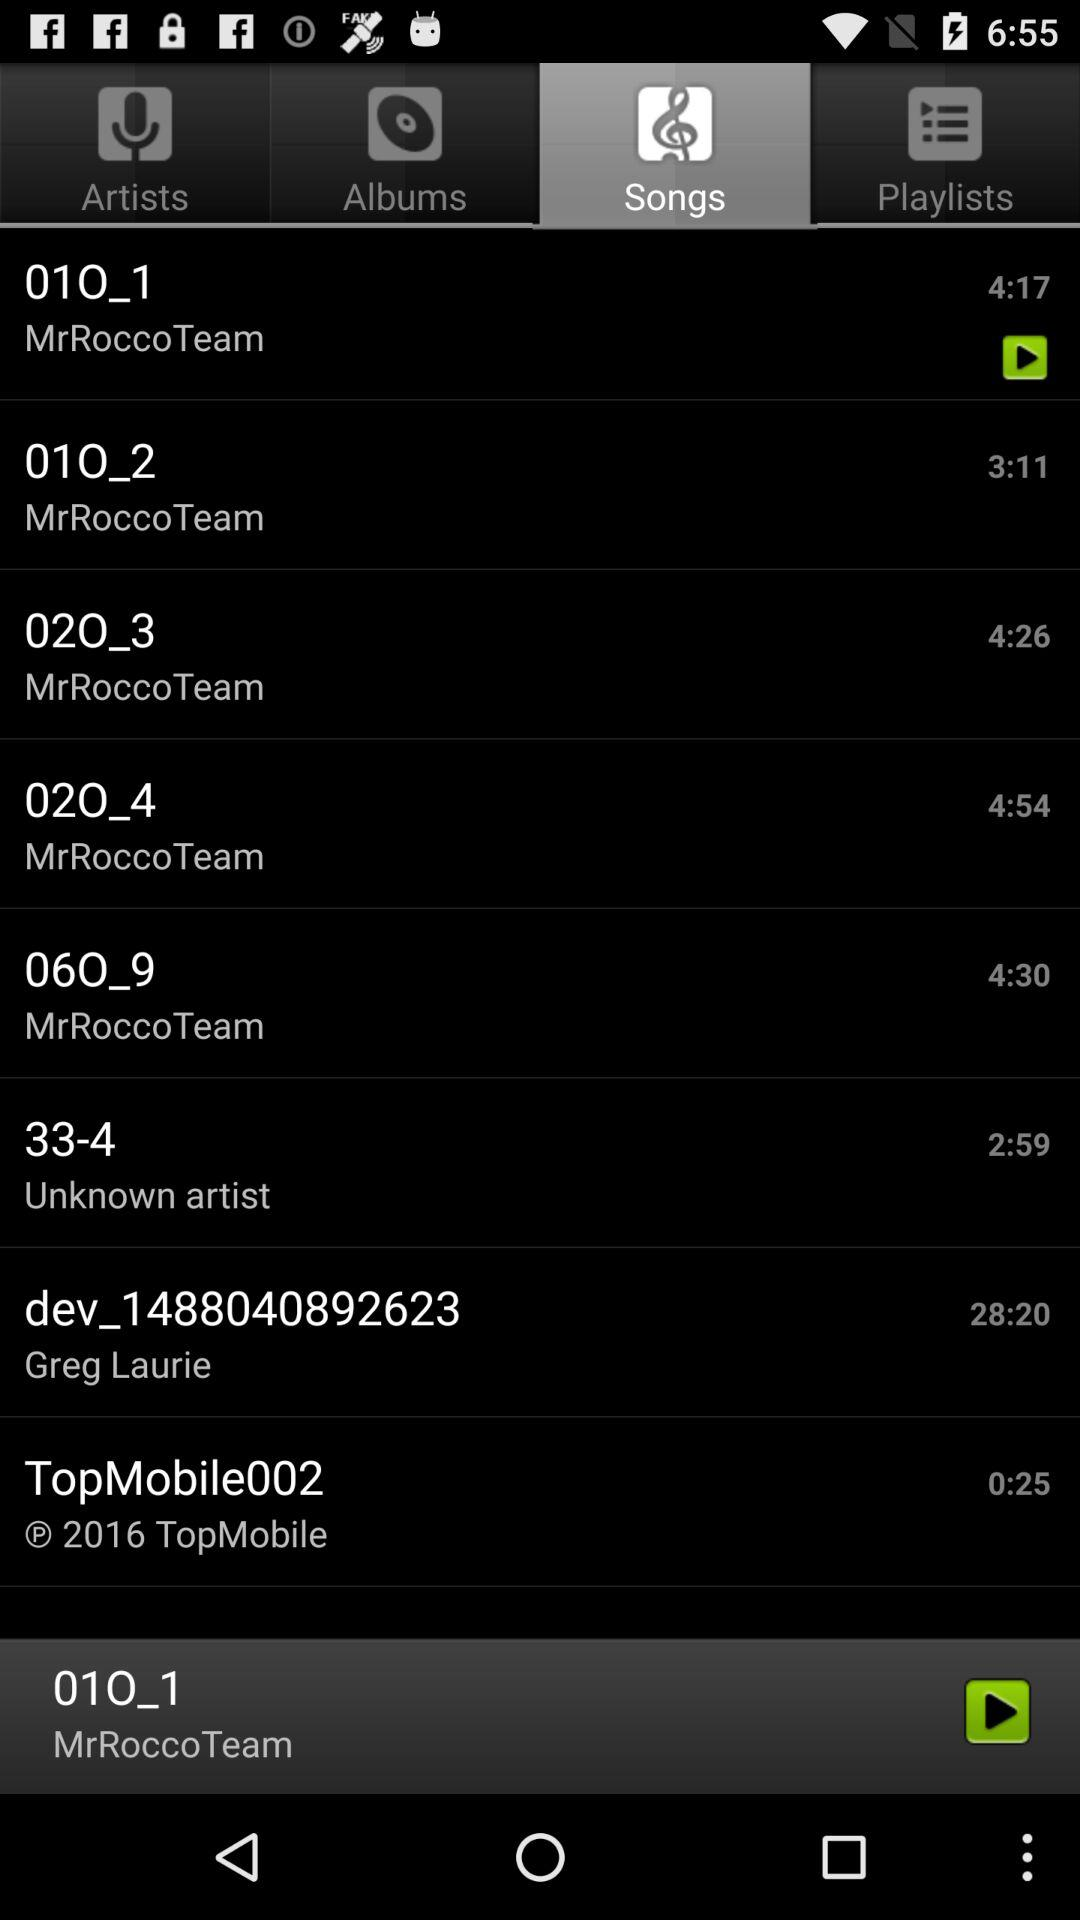Which tab is selected? The selected tab is "Songs". 